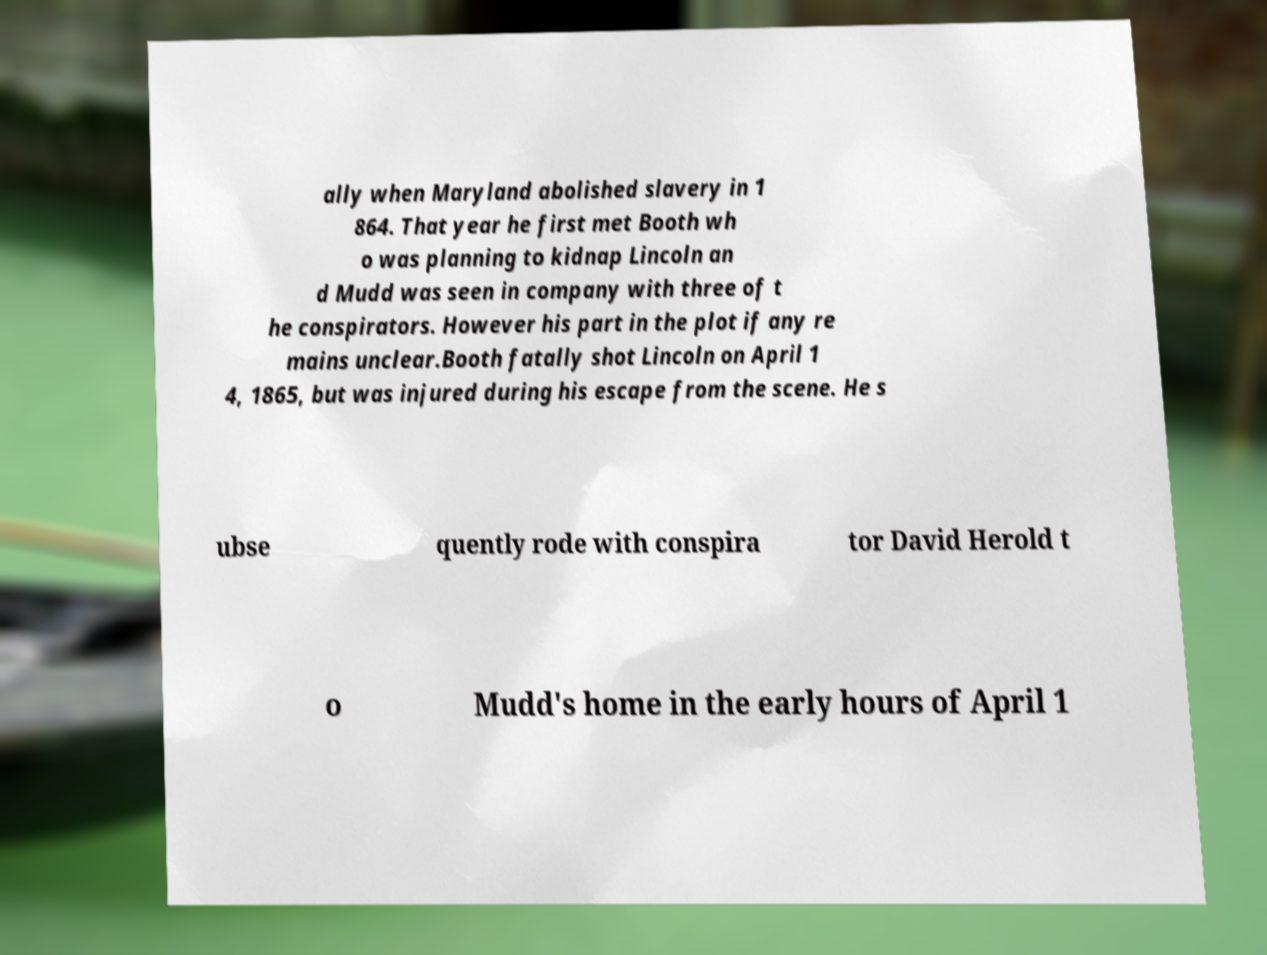I need the written content from this picture converted into text. Can you do that? ally when Maryland abolished slavery in 1 864. That year he first met Booth wh o was planning to kidnap Lincoln an d Mudd was seen in company with three of t he conspirators. However his part in the plot if any re mains unclear.Booth fatally shot Lincoln on April 1 4, 1865, but was injured during his escape from the scene. He s ubse quently rode with conspira tor David Herold t o Mudd's home in the early hours of April 1 